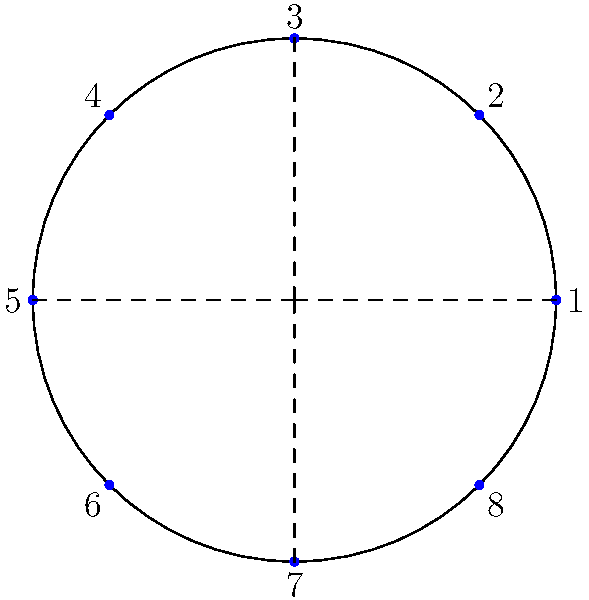In the Stade des Alpes, the home stadium of Grenoble Foot 38, a group of 8 die-hard fans always sit in the same circular arrangement. If the group is represented by the dihedral group $D_8$, how many unique seating arrangements can be created by rotations and reflections? To solve this problem, we need to understand the properties of the dihedral group $D_8$ and how it relates to the seating arrangement:

1. The dihedral group $D_8$ represents the symmetries of a regular octagon, which matches our seating arrangement of 8 fans.

2. The order of $D_8$ (number of elements) is given by the formula $|D_n| = 2n$, where $n$ is the number of vertices (in this case, 8).

3. Therefore, $|D_8| = 2 \times 8 = 16$.

4. These 16 elements consist of:
   - 8 rotations (including the identity rotation)
   - 8 reflections

5. Each of these 16 symmetry operations represents a unique seating arrangement that can be obtained from the original arrangement.

6. The rotations correspond to shifting all fans clockwise by a certain number of positions.

7. The reflections correspond to flipping the seating arrangement across one of the four axes of symmetry (shown as dashed lines in the diagram).

Therefore, the total number of unique seating arrangements that can be created by rotations and reflections is equal to the order of the dihedral group $D_8$, which is 16.
Answer: 16 